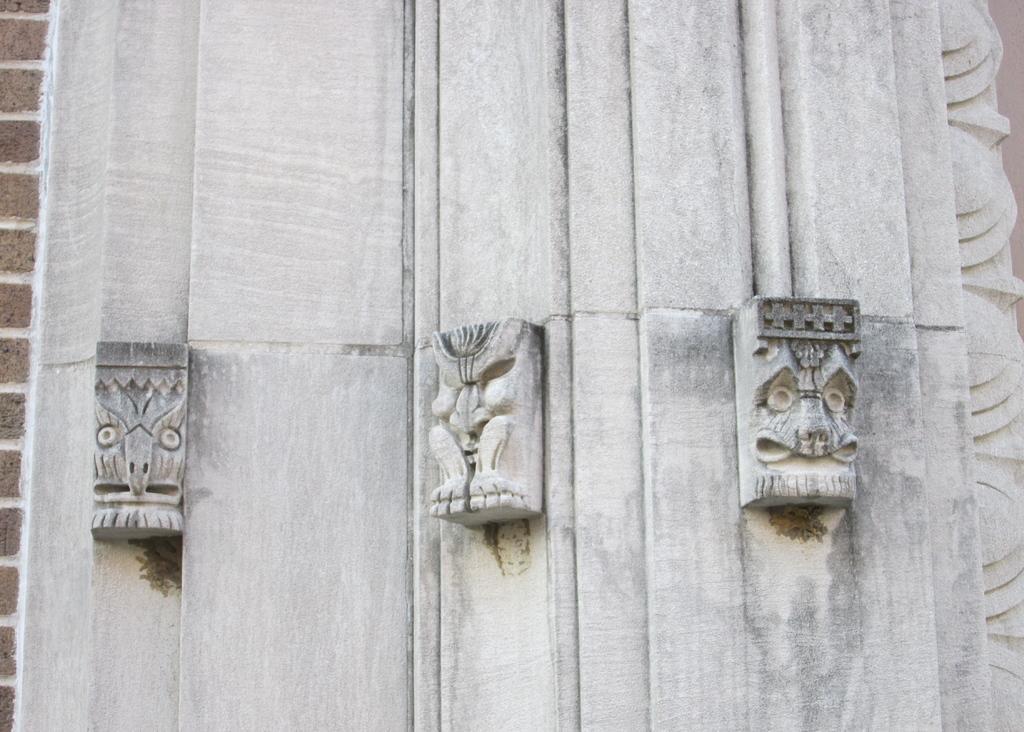Could you give a brief overview of what you see in this image? In this picture, we see a white wall with the stone carved statues. On the left side, we see a wall which is made up of brown colored bricks. 